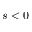<formula> <loc_0><loc_0><loc_500><loc_500>s < 0</formula> 